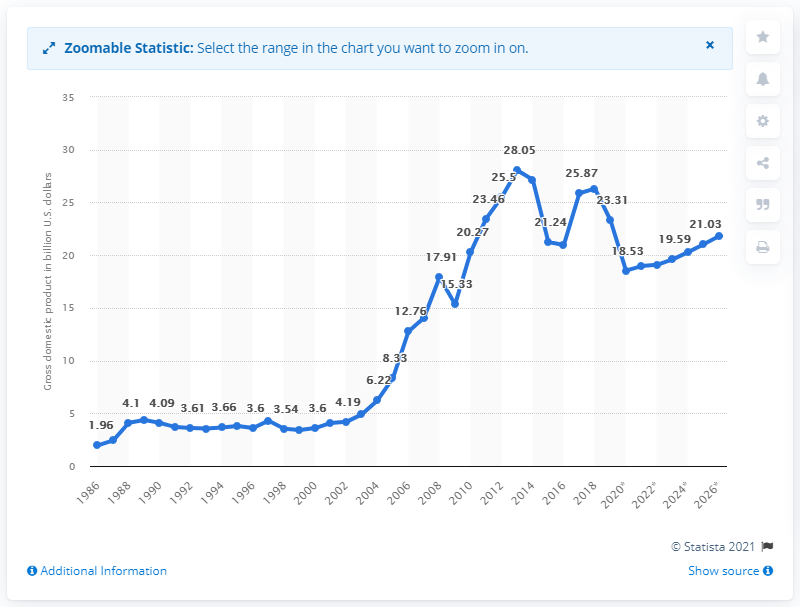List a handful of essential elements in this visual. In 2019, Zambia's gross domestic product (GDP) was valued at 23.31 billion dollars. 